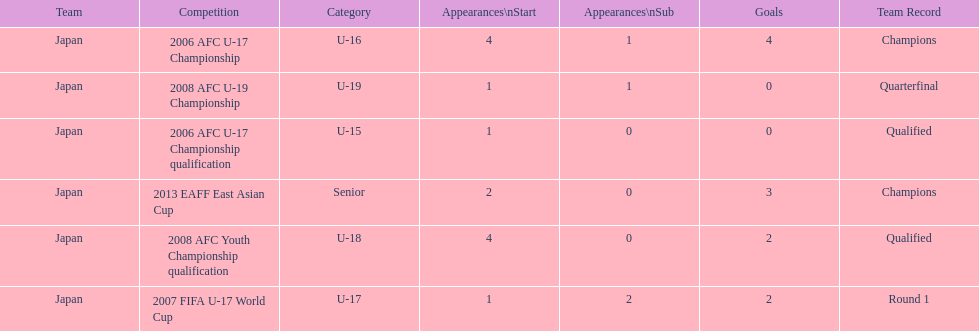What was yoichiro kakitani's first major competition? 2006 AFC U-17 Championship qualification. 